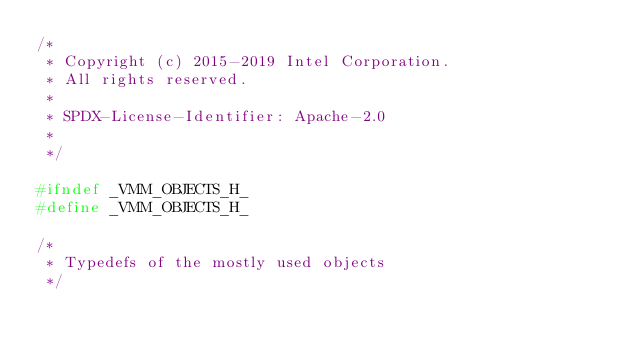<code> <loc_0><loc_0><loc_500><loc_500><_C_>/*
 * Copyright (c) 2015-2019 Intel Corporation.
 * All rights reserved.
 *
 * SPDX-License-Identifier: Apache-2.0
 *
 */

#ifndef _VMM_OBJECTS_H_
#define _VMM_OBJECTS_H_

/*
 * Typedefs of the mostly used objects
 */
</code> 